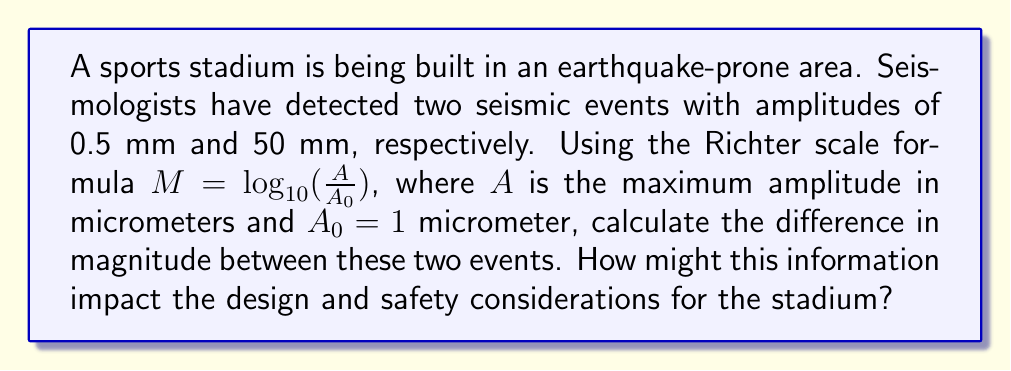Teach me how to tackle this problem. Let's approach this step-by-step:

1) First, we need to convert the amplitudes to micrometers:
   0.5 mm = 500 μm
   50 mm = 50,000 μm

2) Now, let's calculate the magnitude for each event using the Richter scale formula:

   For the 0.5 mm event:
   $$M_1 = \log_{10}(\frac{500}{1}) = \log_{10}(500) = 2.699$$

   For the 50 mm event:
   $$M_2 = \log_{10}(\frac{50000}{1}) = \log_{10}(50000) = 4.699$$

3) To find the difference in magnitude, we subtract:
   $$\Delta M = M_2 - M_1 = 4.699 - 2.699 = 2$$

This 2-point difference on the Richter scale is significant. Each whole number increase on the Richter scale represents a 10-fold increase in amplitude and about 31.6 times more energy released. This information is crucial for stadium designers and engineers to ensure the structure can withstand potential seismic events of varying magnitudes, incorporating appropriate materials and design features to enhance safety and structural integrity.
Answer: 2 